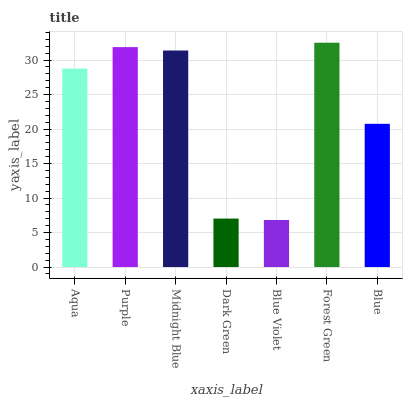Is Blue Violet the minimum?
Answer yes or no. Yes. Is Forest Green the maximum?
Answer yes or no. Yes. Is Purple the minimum?
Answer yes or no. No. Is Purple the maximum?
Answer yes or no. No. Is Purple greater than Aqua?
Answer yes or no. Yes. Is Aqua less than Purple?
Answer yes or no. Yes. Is Aqua greater than Purple?
Answer yes or no. No. Is Purple less than Aqua?
Answer yes or no. No. Is Aqua the high median?
Answer yes or no. Yes. Is Aqua the low median?
Answer yes or no. Yes. Is Forest Green the high median?
Answer yes or no. No. Is Midnight Blue the low median?
Answer yes or no. No. 